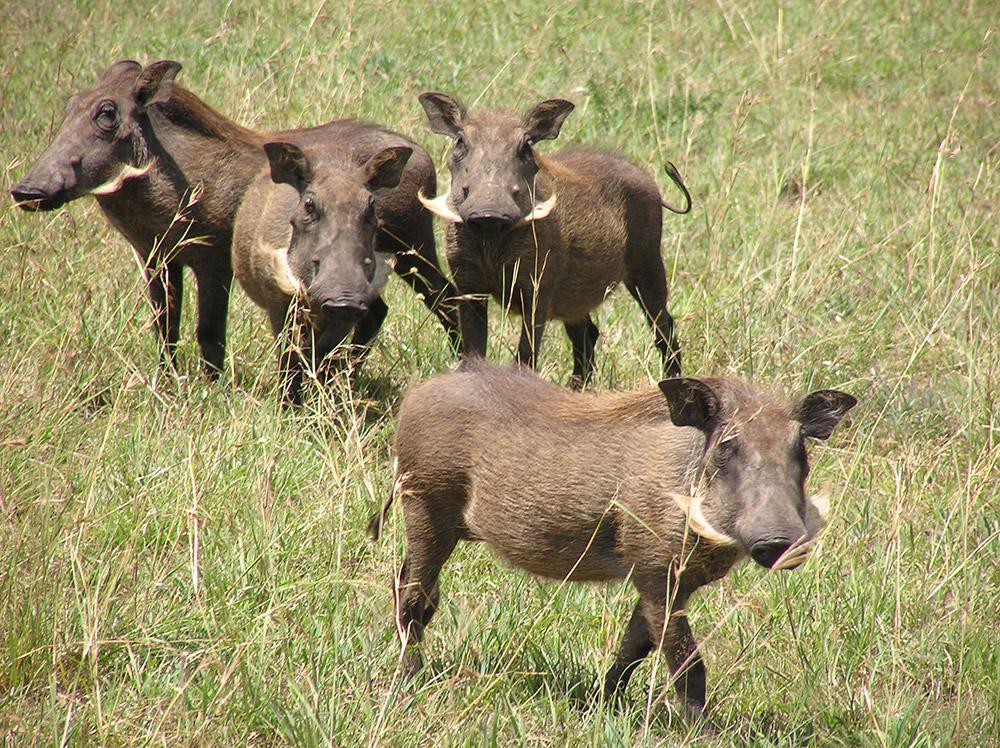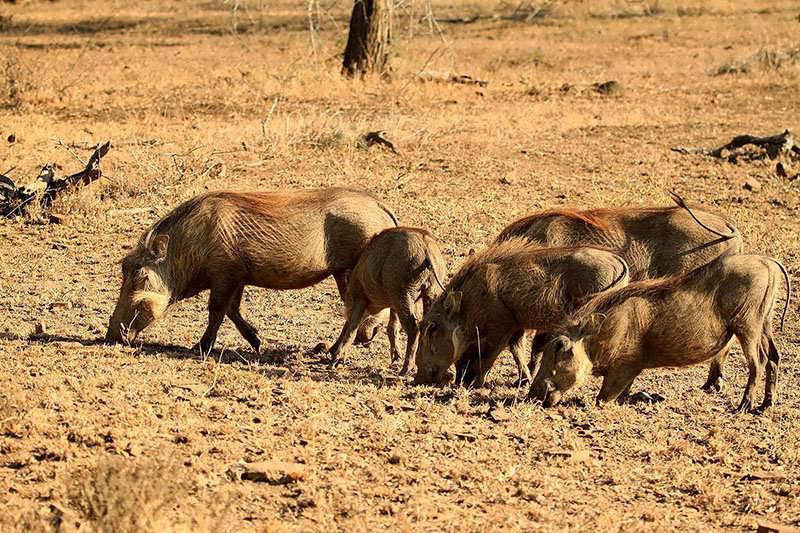The first image is the image on the left, the second image is the image on the right. For the images shown, is this caption "The animals all look the same color" true? Answer yes or no. Yes. The first image is the image on the left, the second image is the image on the right. For the images shown, is this caption "There are five warthogs in the left image." true? Answer yes or no. No. 